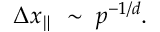Convert formula to latex. <formula><loc_0><loc_0><loc_500><loc_500>\Delta x _ { \| } \, \sim \, p ^ { - 1 / d } .</formula> 